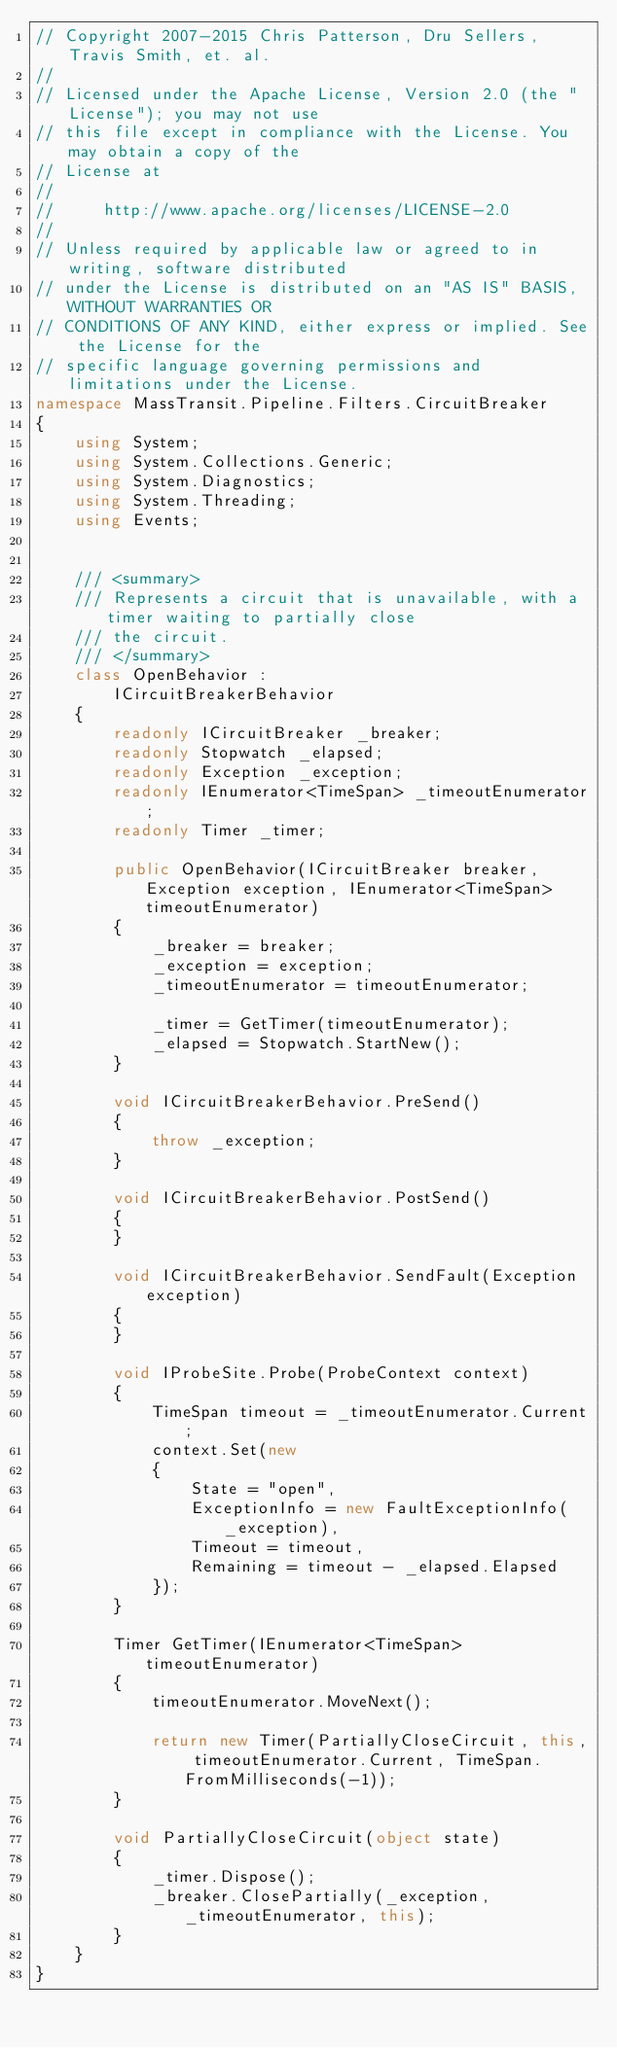<code> <loc_0><loc_0><loc_500><loc_500><_C#_>// Copyright 2007-2015 Chris Patterson, Dru Sellers, Travis Smith, et. al.
//  
// Licensed under the Apache License, Version 2.0 (the "License"); you may not use
// this file except in compliance with the License. You may obtain a copy of the 
// License at 
// 
//     http://www.apache.org/licenses/LICENSE-2.0 
// 
// Unless required by applicable law or agreed to in writing, software distributed
// under the License is distributed on an "AS IS" BASIS, WITHOUT WARRANTIES OR 
// CONDITIONS OF ANY KIND, either express or implied. See the License for the 
// specific language governing permissions and limitations under the License.
namespace MassTransit.Pipeline.Filters.CircuitBreaker
{
    using System;
    using System.Collections.Generic;
    using System.Diagnostics;
    using System.Threading;
    using Events;


    /// <summary>
    /// Represents a circuit that is unavailable, with a timer waiting to partially close
    /// the circuit.
    /// </summary>
    class OpenBehavior :
        ICircuitBreakerBehavior
    {
        readonly ICircuitBreaker _breaker;
        readonly Stopwatch _elapsed;
        readonly Exception _exception;
        readonly IEnumerator<TimeSpan> _timeoutEnumerator;
        readonly Timer _timer;

        public OpenBehavior(ICircuitBreaker breaker, Exception exception, IEnumerator<TimeSpan> timeoutEnumerator)
        {
            _breaker = breaker;
            _exception = exception;
            _timeoutEnumerator = timeoutEnumerator;

            _timer = GetTimer(timeoutEnumerator);
            _elapsed = Stopwatch.StartNew();
        }

        void ICircuitBreakerBehavior.PreSend()
        {
            throw _exception;
        }

        void ICircuitBreakerBehavior.PostSend()
        {
        }

        void ICircuitBreakerBehavior.SendFault(Exception exception)
        {
        }

        void IProbeSite.Probe(ProbeContext context)
        {
            TimeSpan timeout = _timeoutEnumerator.Current;
            context.Set(new
            {
                State = "open",
                ExceptionInfo = new FaultExceptionInfo(_exception),
                Timeout = timeout,
                Remaining = timeout - _elapsed.Elapsed
            });
        }

        Timer GetTimer(IEnumerator<TimeSpan> timeoutEnumerator)
        {
            timeoutEnumerator.MoveNext();

            return new Timer(PartiallyCloseCircuit, this, timeoutEnumerator.Current, TimeSpan.FromMilliseconds(-1));
        }

        void PartiallyCloseCircuit(object state)
        {
            _timer.Dispose();
            _breaker.ClosePartially(_exception, _timeoutEnumerator, this);
        }
    }
}</code> 